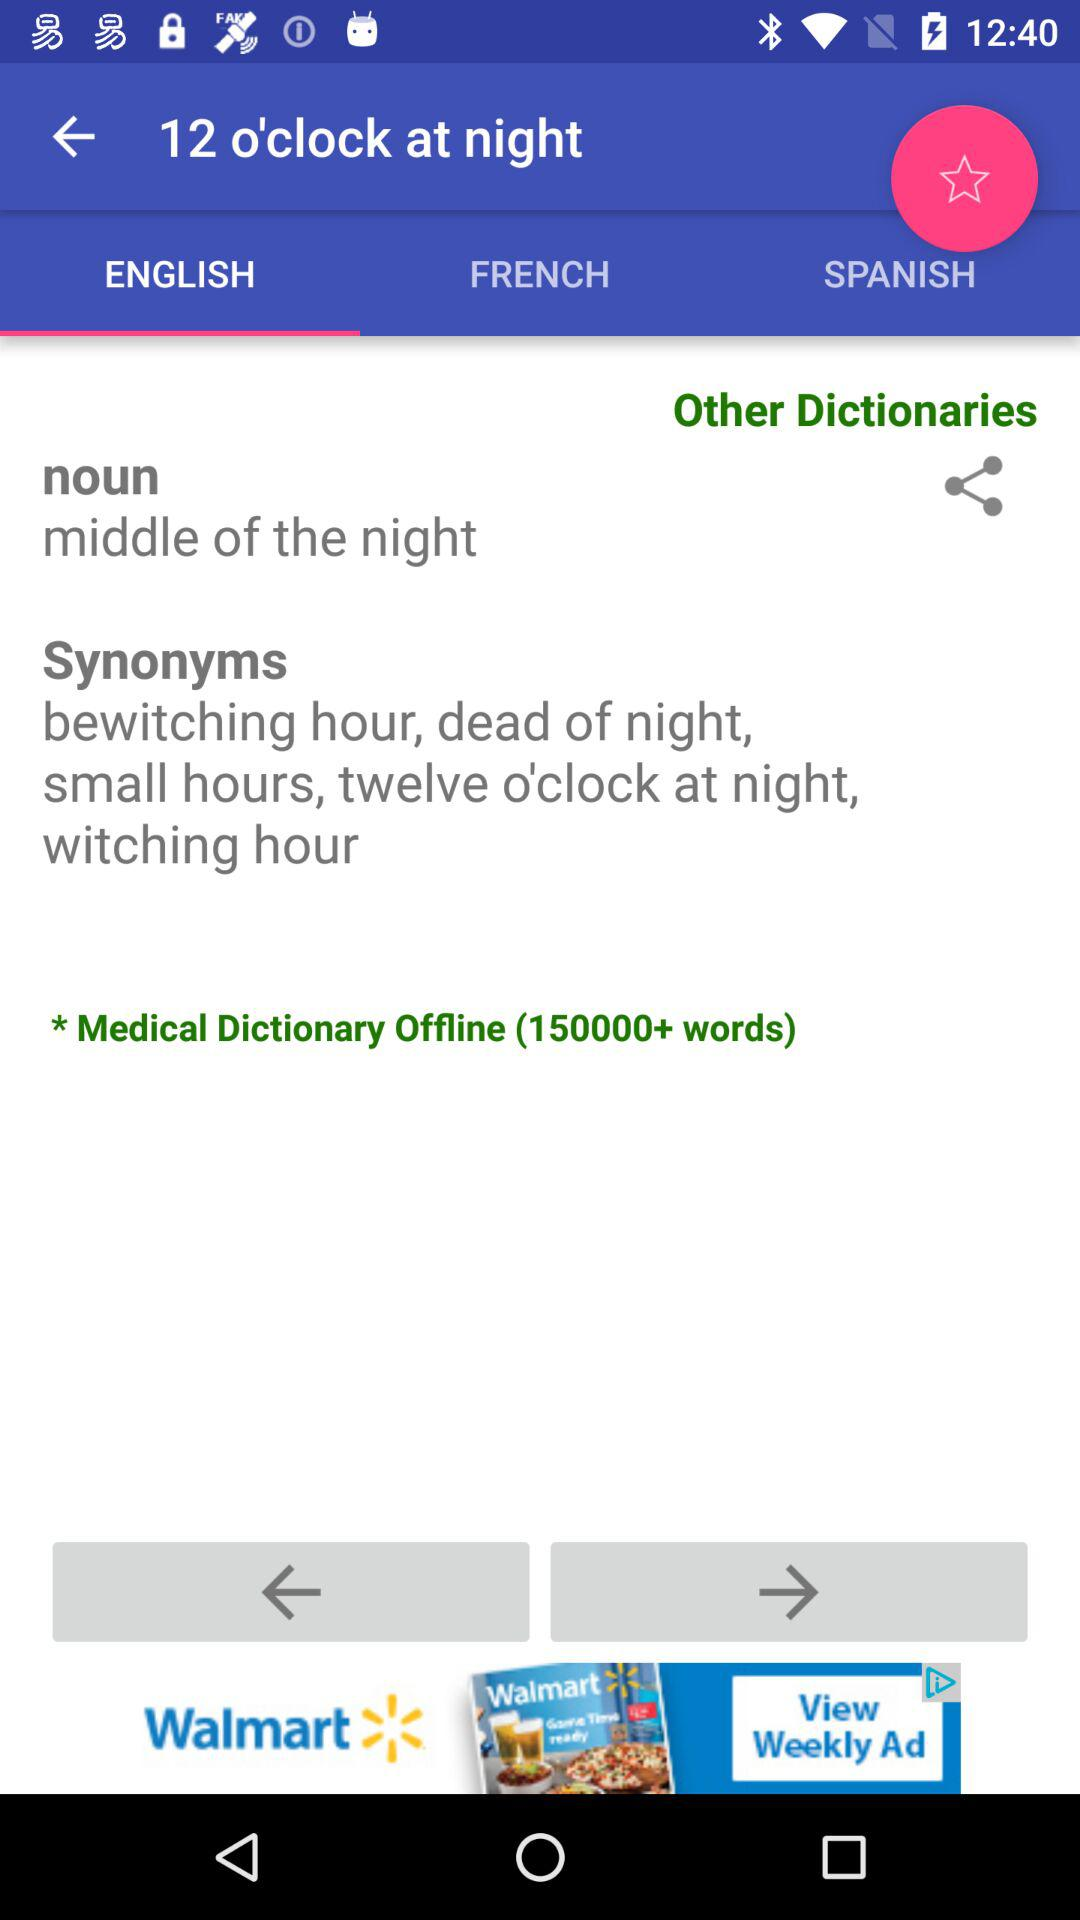What is the time? The time is 12 o'clock at night. 